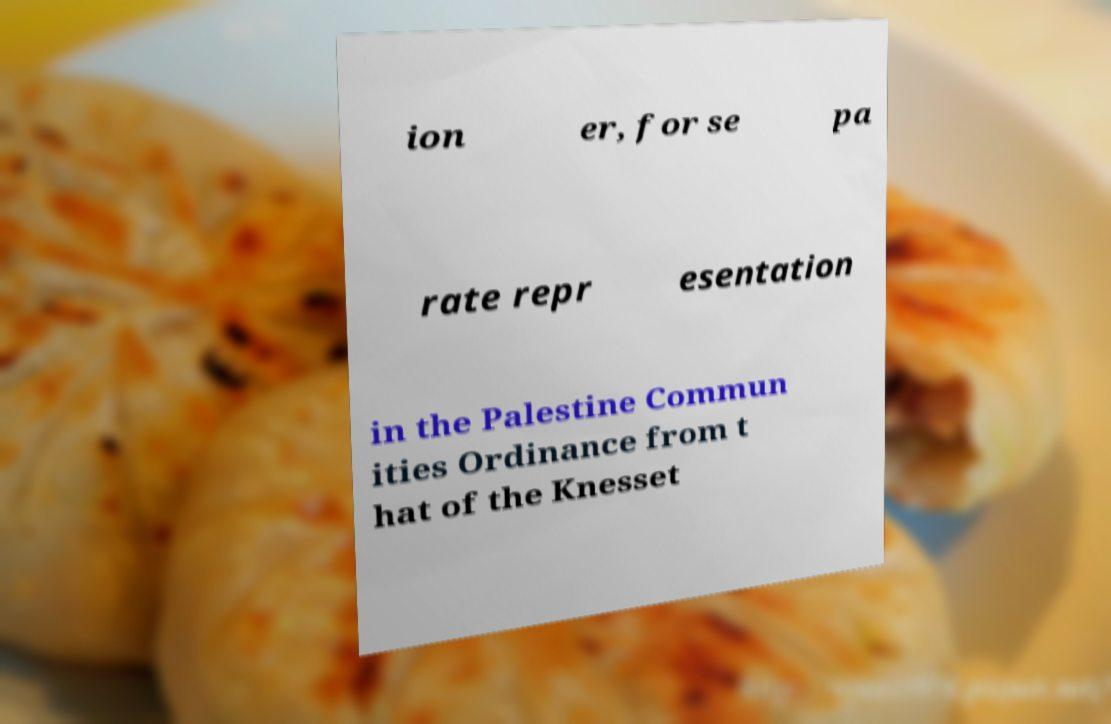There's text embedded in this image that I need extracted. Can you transcribe it verbatim? ion er, for se pa rate repr esentation in the Palestine Commun ities Ordinance from t hat of the Knesset 